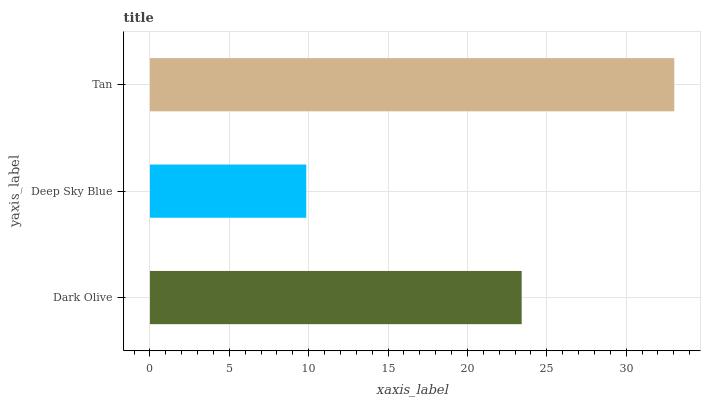Is Deep Sky Blue the minimum?
Answer yes or no. Yes. Is Tan the maximum?
Answer yes or no. Yes. Is Tan the minimum?
Answer yes or no. No. Is Deep Sky Blue the maximum?
Answer yes or no. No. Is Tan greater than Deep Sky Blue?
Answer yes or no. Yes. Is Deep Sky Blue less than Tan?
Answer yes or no. Yes. Is Deep Sky Blue greater than Tan?
Answer yes or no. No. Is Tan less than Deep Sky Blue?
Answer yes or no. No. Is Dark Olive the high median?
Answer yes or no. Yes. Is Dark Olive the low median?
Answer yes or no. Yes. Is Deep Sky Blue the high median?
Answer yes or no. No. Is Deep Sky Blue the low median?
Answer yes or no. No. 